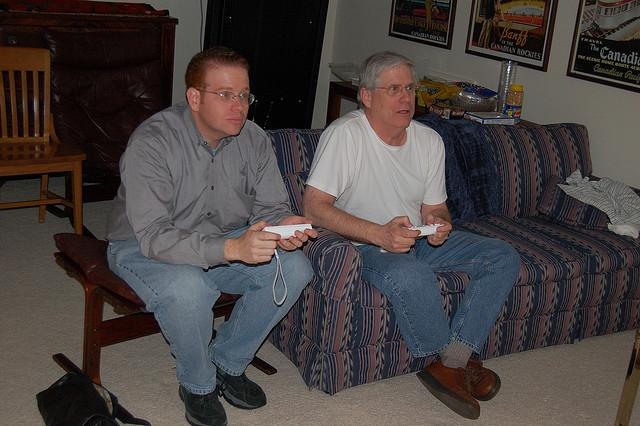What is the name of the white device in the men's hands? game controller 